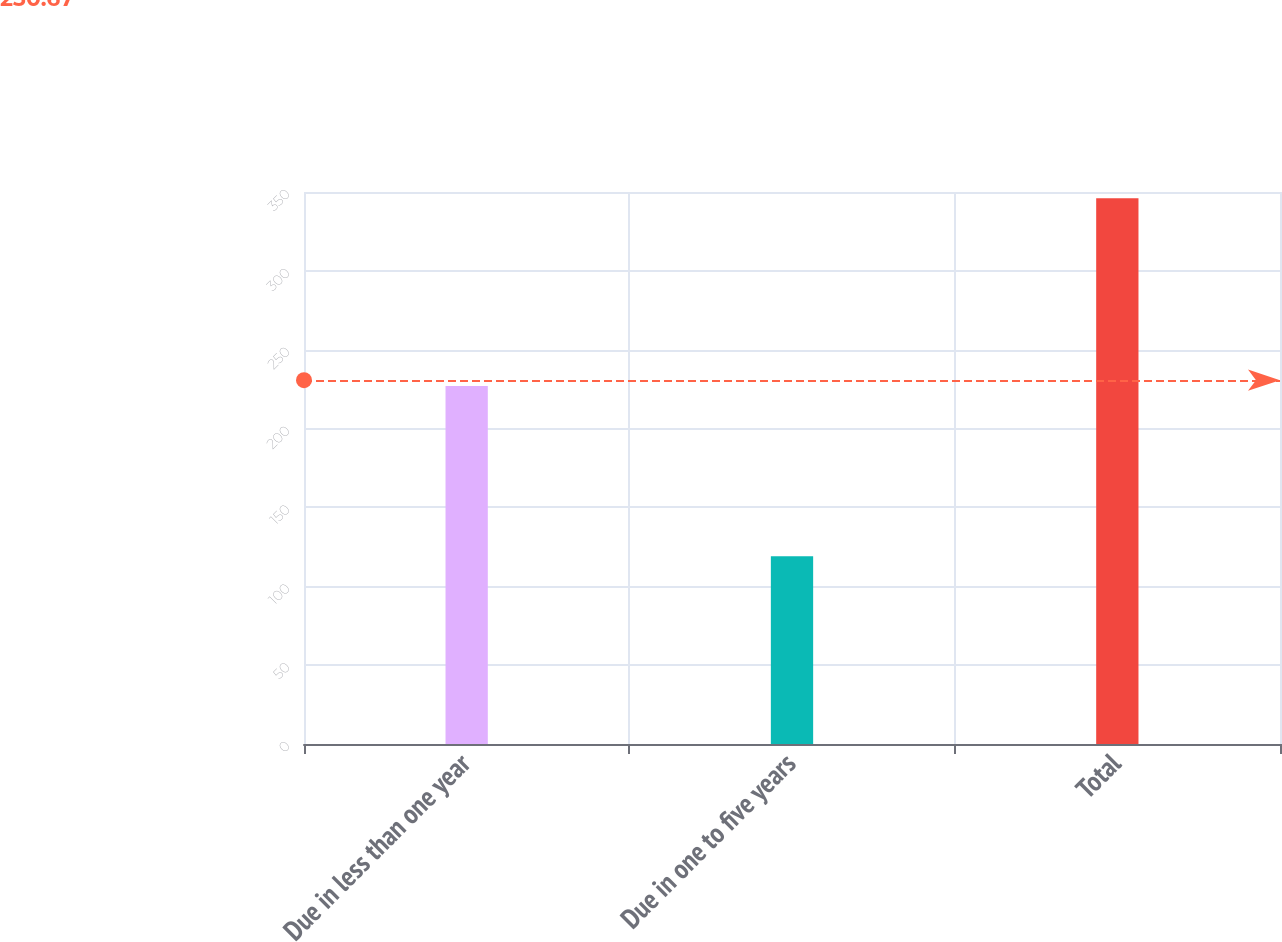<chart> <loc_0><loc_0><loc_500><loc_500><bar_chart><fcel>Due in less than one year<fcel>Due in one to five years<fcel>Total<nl><fcel>227<fcel>119<fcel>346<nl></chart> 